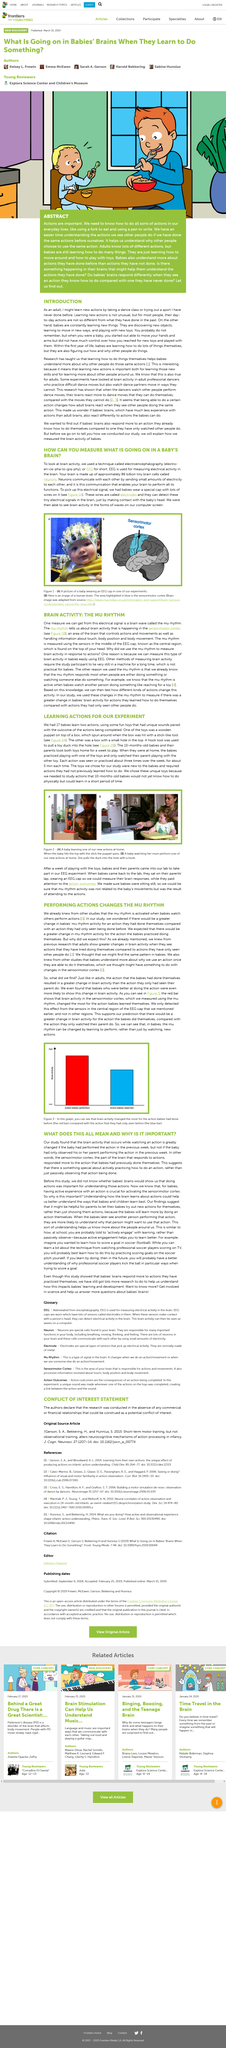Give some essential details in this illustration. The experiment supported the predictions of the researchers that the mu rhythm can be changed by learning to perform, rather than by simply watching. The section of the diagram labeled blue at position B is the Sensorimotor cortex. Figure 2 (A) depicts a baby learning a new action at home. In this experiment, a total of 17 babies learned two new actions. This study draws on previous research that has investigated the effects of watching others perform on the mu rhythm in both infants and adults. 